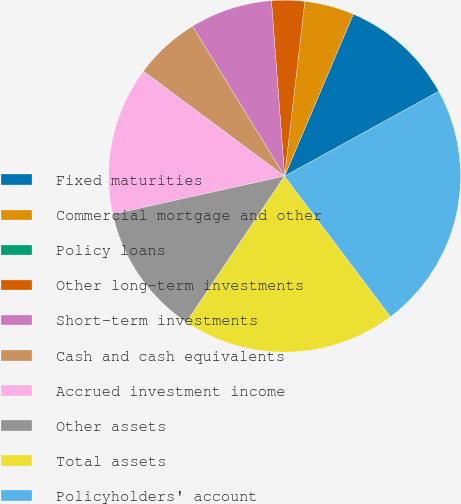<chart> <loc_0><loc_0><loc_500><loc_500><pie_chart><fcel>Fixed maturities<fcel>Commercial mortgage and other<fcel>Policy loans<fcel>Other long-term investments<fcel>Short-term investments<fcel>Cash and cash equivalents<fcel>Accrued investment income<fcel>Other assets<fcel>Total assets<fcel>Policyholders' account<nl><fcel>10.61%<fcel>4.55%<fcel>0.0%<fcel>3.03%<fcel>7.58%<fcel>6.06%<fcel>13.64%<fcel>12.12%<fcel>19.7%<fcel>22.73%<nl></chart> 